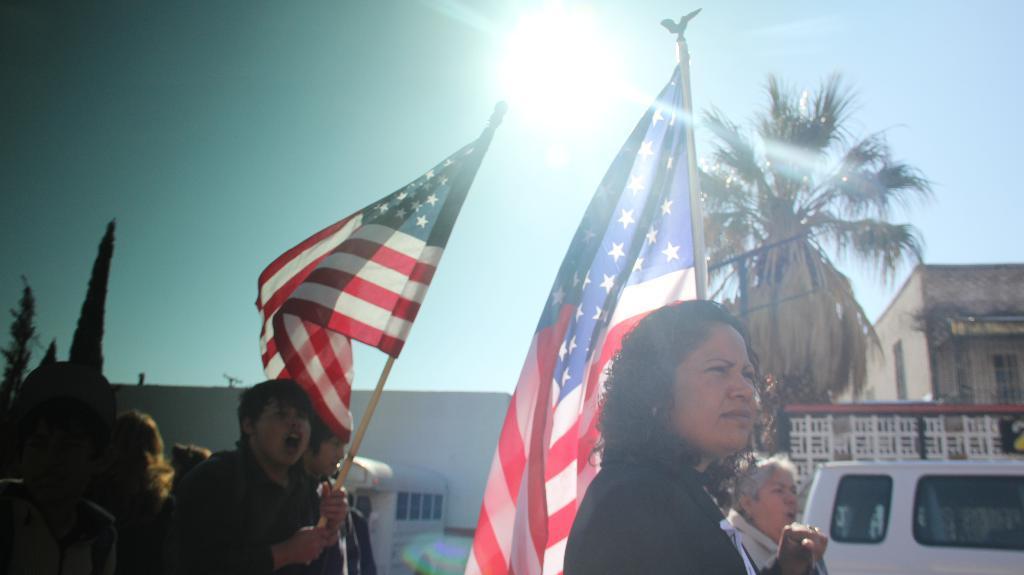Can you describe this image briefly? In this image I can see few people and holding flags and the flags are in blue, red and white color. Background I can see few vehicles, buildings in white and cream color, trees in green color and the sky is in blue and white color. 